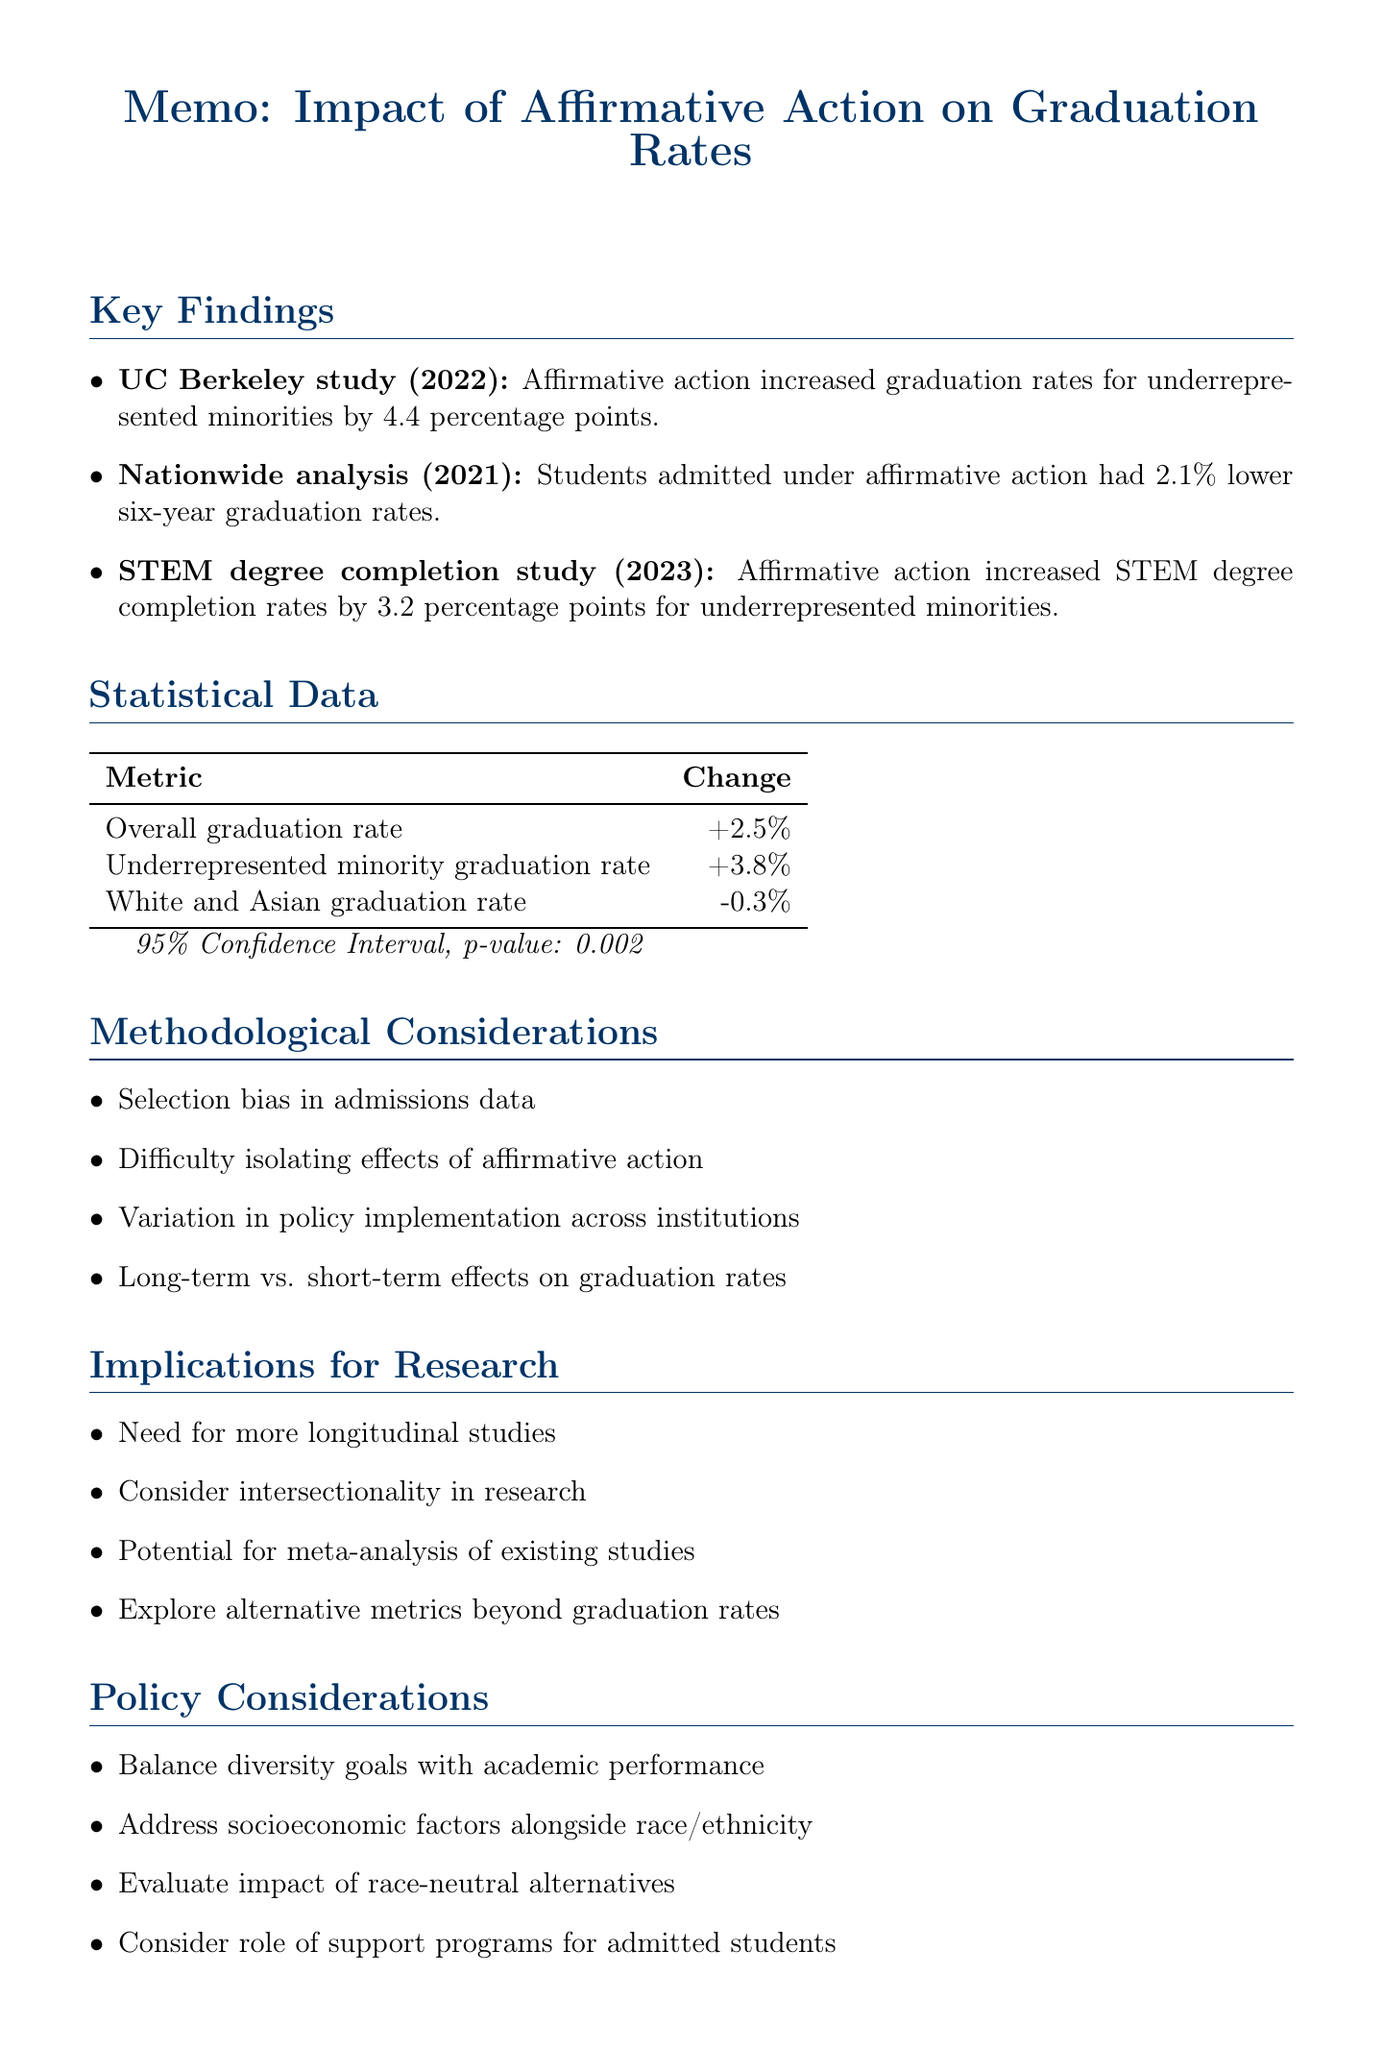What is the sample size of the UC Berkeley study? The sample size for the UC Berkeley study is explicitly stated in the document as 24680.
Answer: 24680 What is the key result of the STEM degree completion study? The document specifies that the STEM degree completion study found an increase in STEM degree completion rates by 3.2 percentage points for underrepresented minorities.
Answer: 3.2 percentage points What was the year of the nationwide analysis study? The document mentions that the nationwide analysis study was published in the year 2021.
Answer: 2021 What is the change in the overall graduation rate? The change in the overall graduation rate is indicated in the document as +2.5%.
Answer: +2.5% What methodological consideration relates to admissions data? The document points out that there is a selection bias in admissions data as a methodological consideration.
Answer: Selection bias in admissions data What is the confidence interval reported in the statistical data? The confidence interval is reported as 95% in the statistical data section of the document.
Answer: 95% Which institution is mentioned as relevant for the research? Harvard University is among the relevant institutions listed in the document.
Answer: Harvard University What is the implication for research related to study types? The document suggests the need for more longitudinal studies to assess long-term impacts as an implication for research.
Answer: More longitudinal studies What does the document suggest should be balanced with academic performance metrics? The document states that diversity goals should be balanced with academic performance metrics.
Answer: Diversity goals 